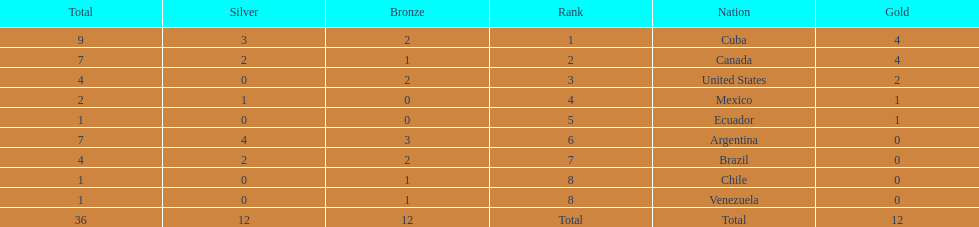Which nation achieved gold but didn't accomplish silver? United States. 